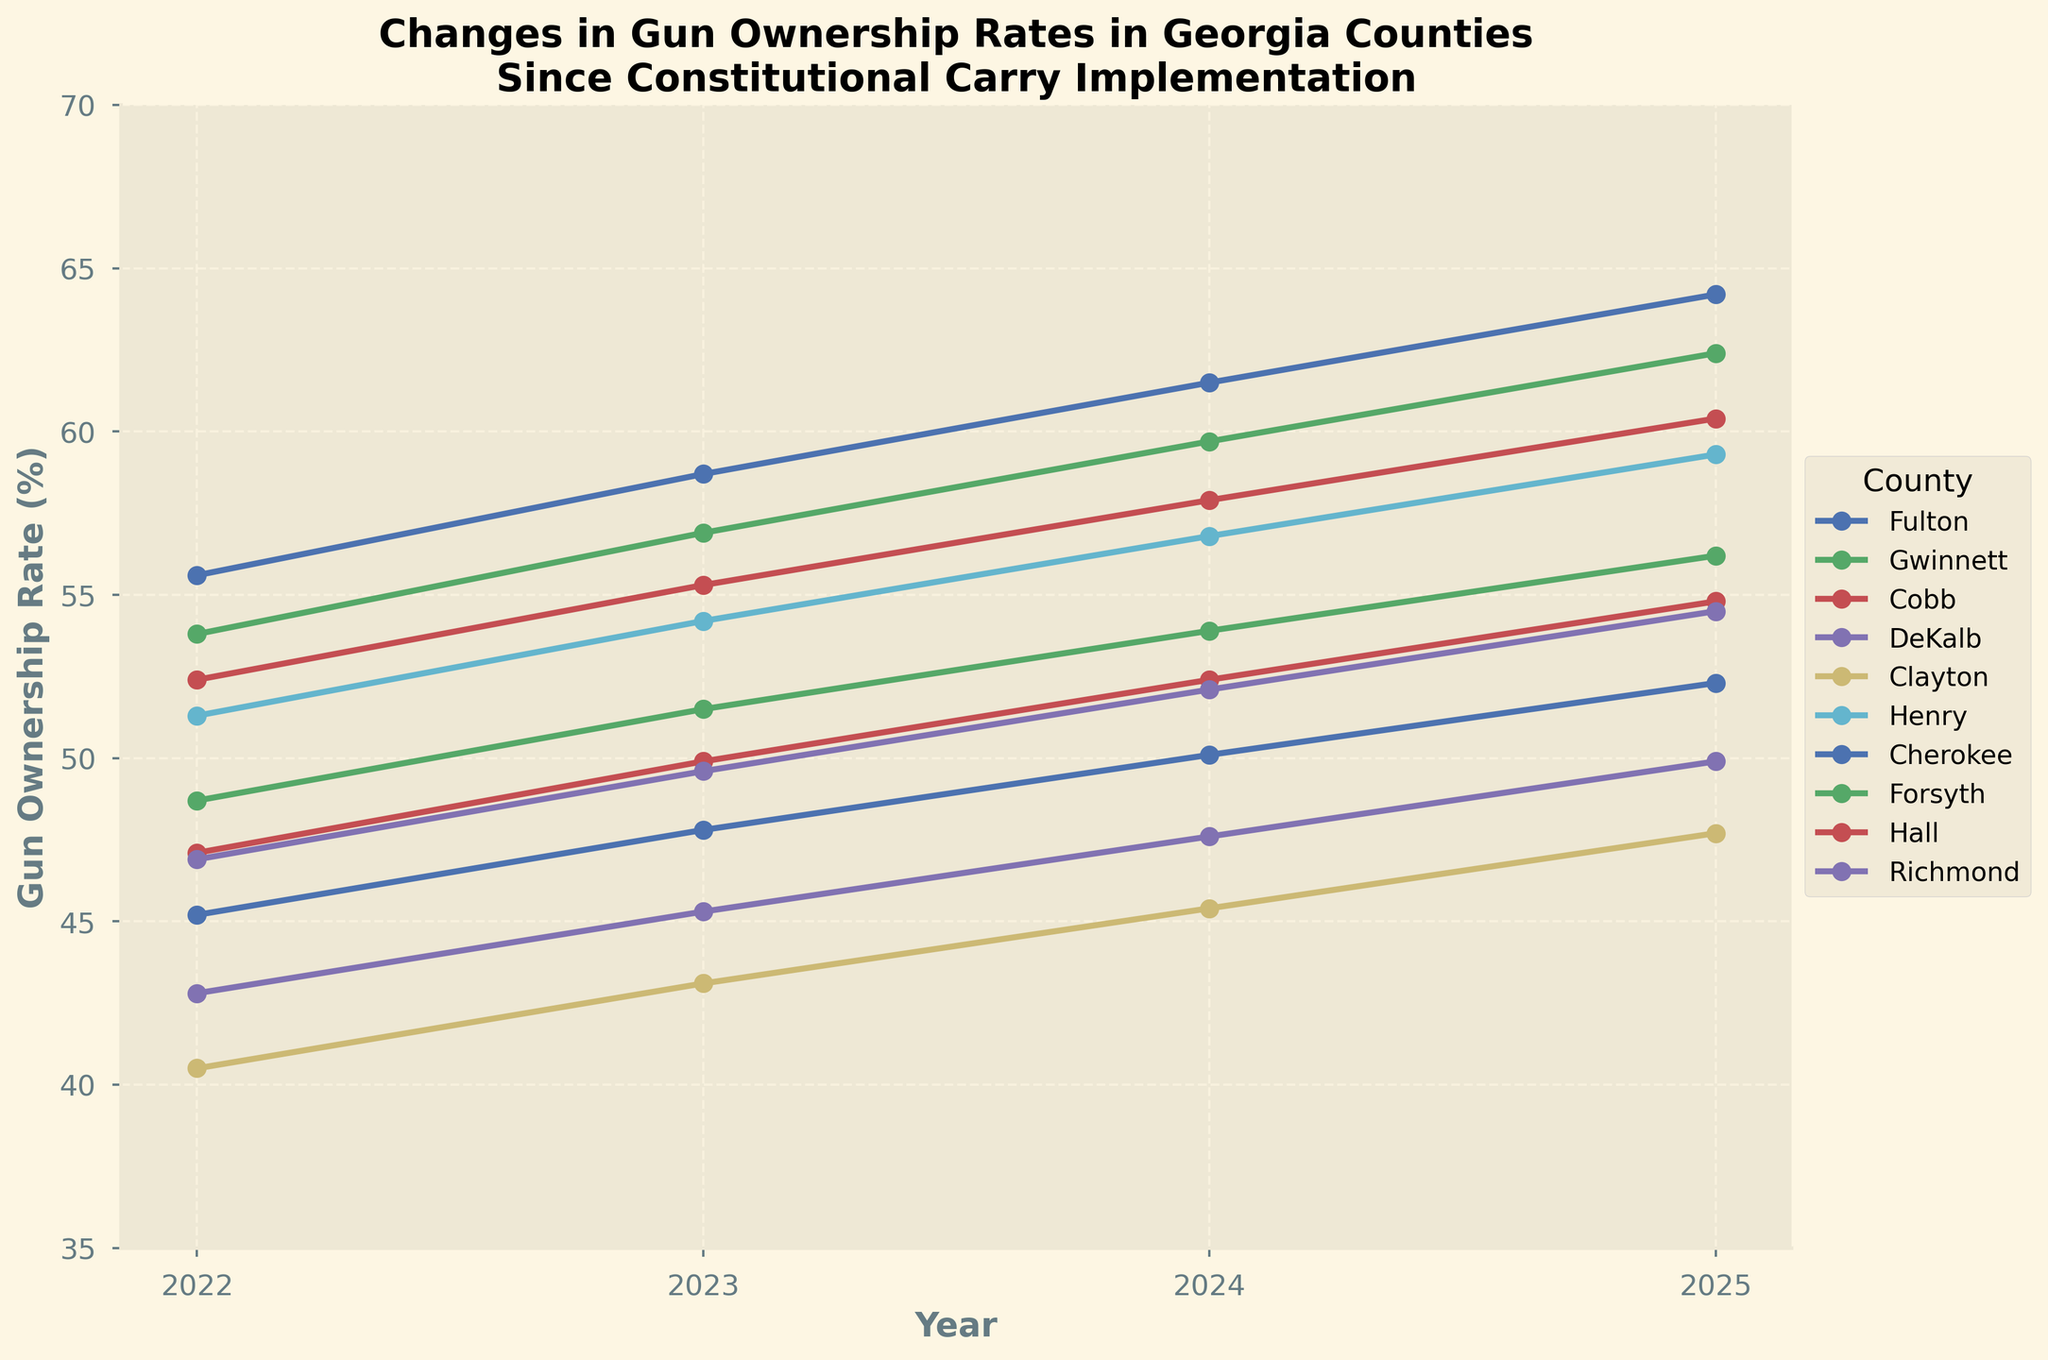What is the difference in the gun ownership rate in Clayton County between 2022 and 2025? To find the difference, subtract the 2022 rate from the 2025 rate: 47.7 - 40.5 = 7.2.
Answer: 7.2 Which county had the highest gun ownership rate in 2025? Look at the 2025 column and identify the highest value, which is 64.2 in Cherokee County.
Answer: Cherokee By how much did the gun ownership rate in Fulton County increase from 2022 to 2024? Subtract the 2022 rate from the 2024 rate: 50.1 - 45.2 = 4.9.
Answer: 4.9 Which county had the lowest gun ownership rate in 2023, and what was the rate? Look at the 2023 column and identify the lowest value, which is 43.1 in Clayton County.
Answer: Clayton, 43.1 What is the average gun ownership rate across all counties in 2025? Add all the 2025 rates and divide by the number of counties: (52.3 + 56.2 + 54.8 + 49.9 + 47.7 + 59.3 + 64.2 + 62.4 + 60.4 + 54.5) / 10 = 56.17
Answer: 56.17 How does the gun ownership rate change in Cherokee County compare to that in DeKalb County from 2022 to 2025? Calculate the increase: Cherokee (64.2 - 55.6 = 8.6), DeKalb (49.9 - 42.8 = 7.1). Cherokee increased by 8.6%, and DeKalb increased by 7.1%. Cherokee had a higher increase.
Answer: Cherokee increased more by 1.5 Which county shows the largest increase in gun ownership rate from 2022 to 2025? Calculate the increases for each county and identify the largest: Cherokee (8.6), DeKalb (7.1), Fulton (7.1), etc. Cherokee has the largest increase of 8.6.
Answer: Cherokee What is the trend in gun ownership rates in Gwinnett County across the years? The values are 48.7, 51.5, 53.9, and 56.2, which shows a continuous increase each year.
Answer: Increasing Between Forsyth and Hall counties, which had a higher gun ownership rate in 2024, and by how much? Forsyth in 2024: 59.7. Hall in 2024: 57.9. Difference: 59.7 - 57.9 = 1.8.
Answer: Forsyth, 1.8 If we average the gun ownership rates over the four years for Richmond County, what is the value? (46.9 + 49.6 + 52.1 + 54.5) / 4 = 50.775
Answer: 50.775 